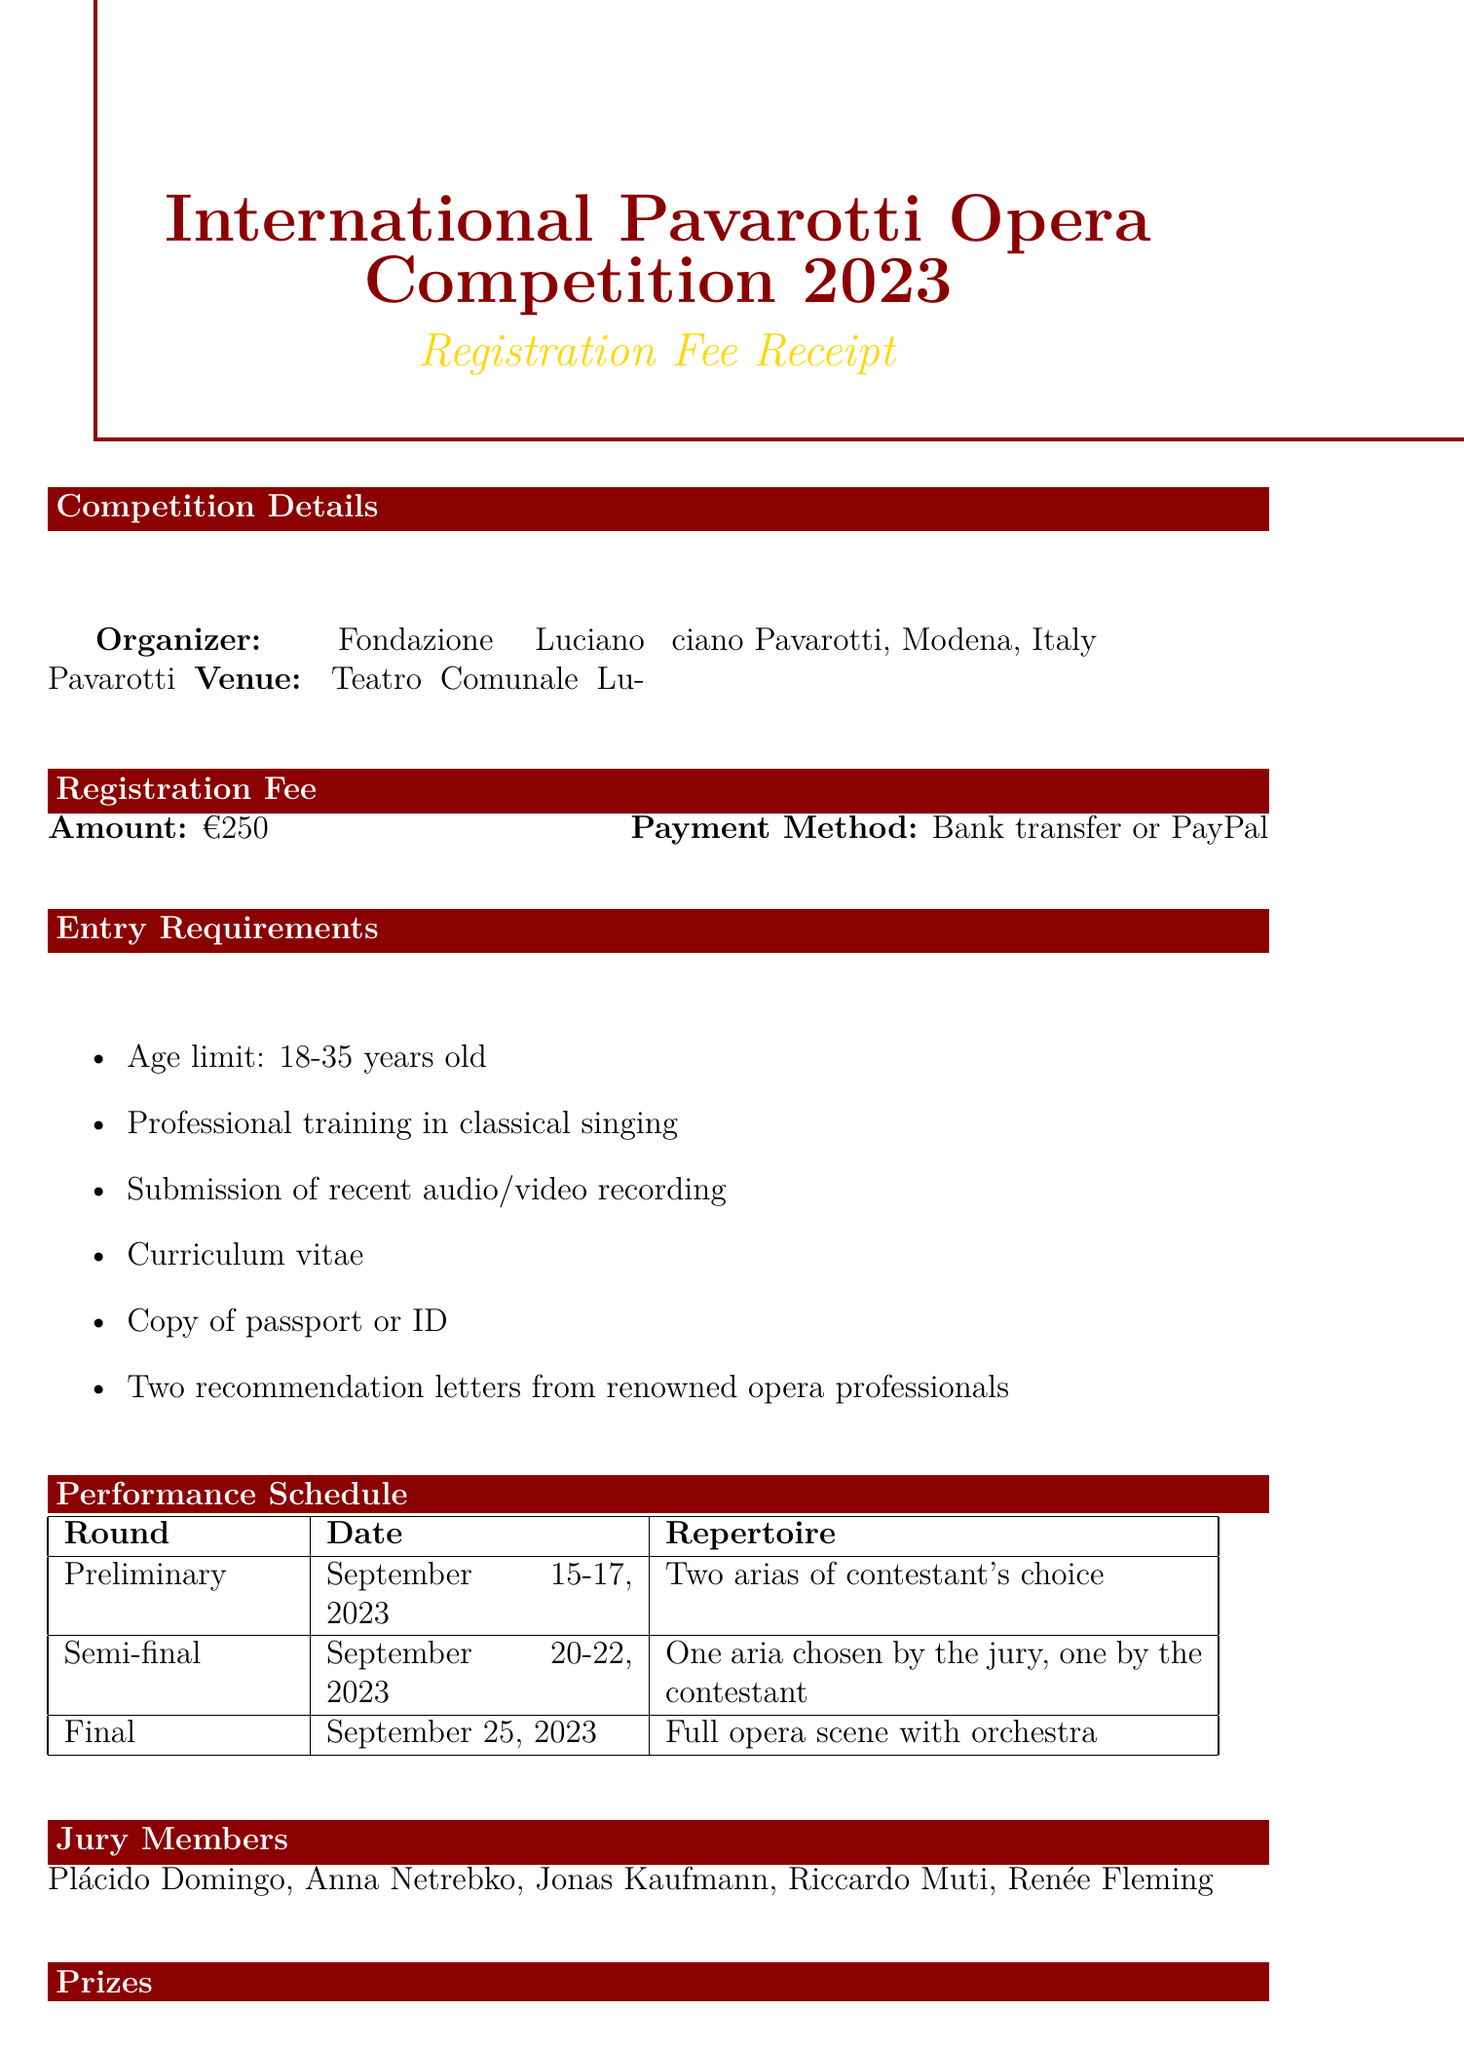What is the registration fee? The registration fee is explicitly stated in the document as €250.
Answer: €250 Who is the organizer of the competition? The organizer of the competition is mentioned as Fondazione Luciano Pavarotti.
Answer: Fondazione Luciano Pavarotti What are the ages eligible to participate? The document specifies an age limit of 18-35 years old for participants.
Answer: 18-35 years old What is the date of the final round? The date for the final round is given as September 25, 2023.
Answer: September 25, 2023 What type of repertoire is required for the semi-final? The repertoire for the semi-final includes one aria chosen by the jury and one by the contestant.
Answer: One aria chosen by the jury, one by the contestant Who are two of the jury members? The document lists multiple jury members, and a question about any two can be answered from that list.
Answer: Plácido Domingo, Anna Netrebko What can participants expect to receive if they win 1st place? The document lists the benefits for the 1st place winner, including the prize amount and performance opportunity.
Answer: €30,000, Performance opportunity at Teatro alla Scala What is the application deadline? The document explicitly states the application deadline as July 31, 2023.
Answer: July 31, 2023 What should participants arrange for themselves? The document notes that participants are responsible for their own travel and accommodation arrangements.
Answer: Travel and accommodation arrangements 